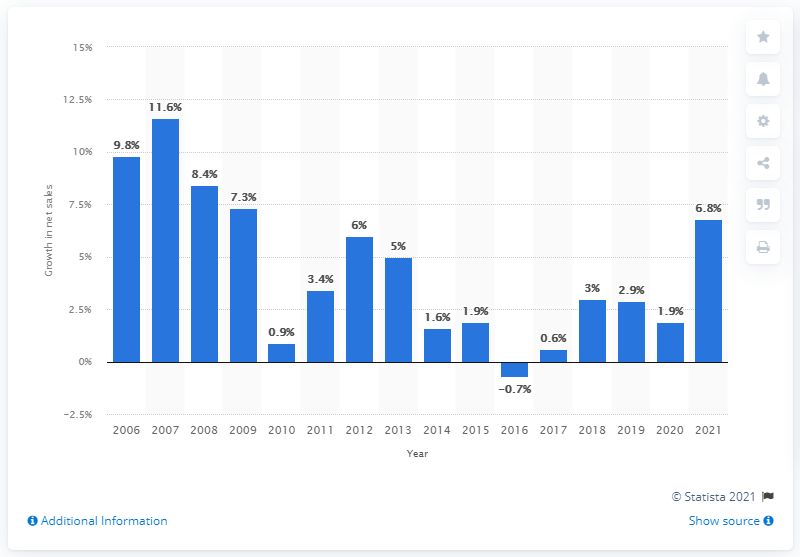Specify some key components in this picture. Walmart's global net sales increased by 6.8% in 2021. 